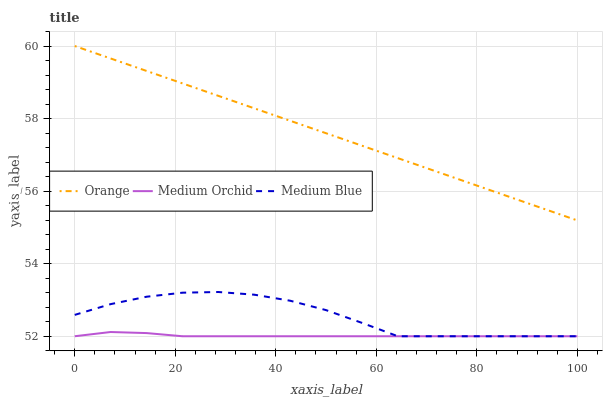Does Medium Orchid have the minimum area under the curve?
Answer yes or no. Yes. Does Orange have the maximum area under the curve?
Answer yes or no. Yes. Does Medium Blue have the minimum area under the curve?
Answer yes or no. No. Does Medium Blue have the maximum area under the curve?
Answer yes or no. No. Is Orange the smoothest?
Answer yes or no. Yes. Is Medium Blue the roughest?
Answer yes or no. Yes. Is Medium Orchid the smoothest?
Answer yes or no. No. Is Medium Orchid the roughest?
Answer yes or no. No. Does Medium Orchid have the lowest value?
Answer yes or no. Yes. Does Orange have the highest value?
Answer yes or no. Yes. Does Medium Blue have the highest value?
Answer yes or no. No. Is Medium Blue less than Orange?
Answer yes or no. Yes. Is Orange greater than Medium Orchid?
Answer yes or no. Yes. Does Medium Orchid intersect Medium Blue?
Answer yes or no. Yes. Is Medium Orchid less than Medium Blue?
Answer yes or no. No. Is Medium Orchid greater than Medium Blue?
Answer yes or no. No. Does Medium Blue intersect Orange?
Answer yes or no. No. 